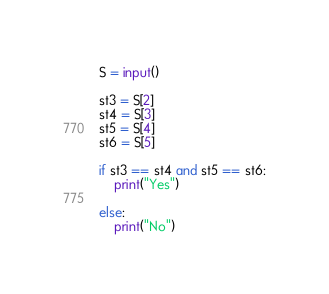<code> <loc_0><loc_0><loc_500><loc_500><_Python_>S = input()

st3 = S[2]
st4 = S[3]
st5 = S[4]
st6 = S[5]

if st3 == st4 and st5 == st6:
    print("Yes")

else:
    print("No")</code> 